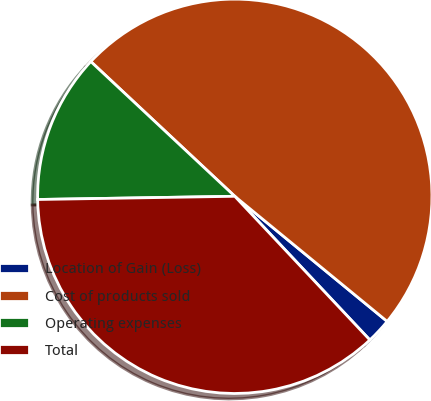Convert chart to OTSL. <chart><loc_0><loc_0><loc_500><loc_500><pie_chart><fcel>Location of Gain (Loss)<fcel>Cost of products sold<fcel>Operating expenses<fcel>Total<nl><fcel>2.05%<fcel>48.97%<fcel>12.23%<fcel>36.75%<nl></chart> 